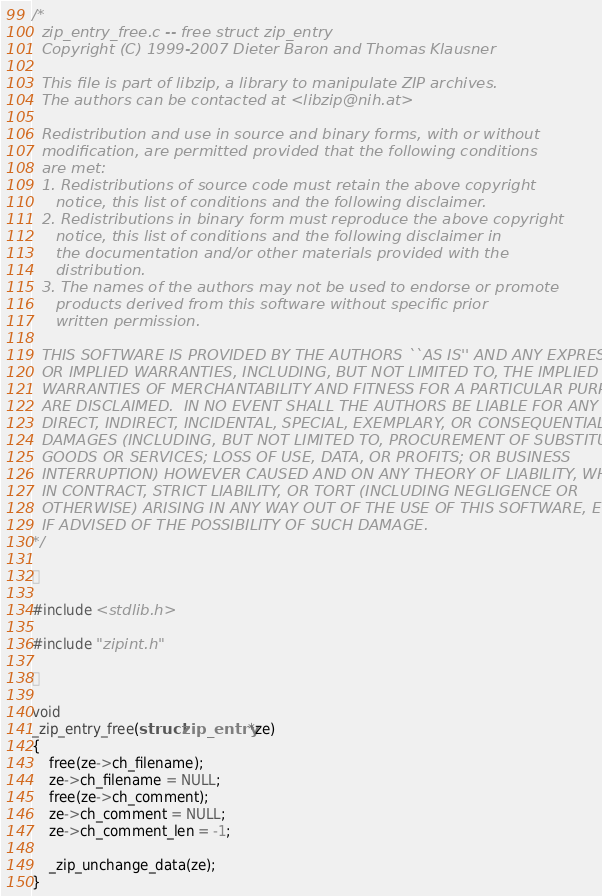Convert code to text. <code><loc_0><loc_0><loc_500><loc_500><_C_>/*
  zip_entry_free.c -- free struct zip_entry
  Copyright (C) 1999-2007 Dieter Baron and Thomas Klausner

  This file is part of libzip, a library to manipulate ZIP archives.
  The authors can be contacted at <libzip@nih.at>

  Redistribution and use in source and binary forms, with or without
  modification, are permitted provided that the following conditions
  are met:
  1. Redistributions of source code must retain the above copyright
     notice, this list of conditions and the following disclaimer.
  2. Redistributions in binary form must reproduce the above copyright
     notice, this list of conditions and the following disclaimer in
     the documentation and/or other materials provided with the
     distribution.
  3. The names of the authors may not be used to endorse or promote
     products derived from this software without specific prior
     written permission.
 
  THIS SOFTWARE IS PROVIDED BY THE AUTHORS ``AS IS'' AND ANY EXPRESS
  OR IMPLIED WARRANTIES, INCLUDING, BUT NOT LIMITED TO, THE IMPLIED
  WARRANTIES OF MERCHANTABILITY AND FITNESS FOR A PARTICULAR PURPOSE
  ARE DISCLAIMED.  IN NO EVENT SHALL THE AUTHORS BE LIABLE FOR ANY
  DIRECT, INDIRECT, INCIDENTAL, SPECIAL, EXEMPLARY, OR CONSEQUENTIAL
  DAMAGES (INCLUDING, BUT NOT LIMITED TO, PROCUREMENT OF SUBSTITUTE
  GOODS OR SERVICES; LOSS OF USE, DATA, OR PROFITS; OR BUSINESS
  INTERRUPTION) HOWEVER CAUSED AND ON ANY THEORY OF LIABILITY, WHETHER
  IN CONTRACT, STRICT LIABILITY, OR TORT (INCLUDING NEGLIGENCE OR
  OTHERWISE) ARISING IN ANY WAY OUT OF THE USE OF THIS SOFTWARE, EVEN
  IF ADVISED OF THE POSSIBILITY OF SUCH DAMAGE.
*/



#include <stdlib.h>

#include "zipint.h"



void
_zip_entry_free(struct zip_entry *ze)
{
    free(ze->ch_filename);
    ze->ch_filename = NULL;
    free(ze->ch_comment);
    ze->ch_comment = NULL;
    ze->ch_comment_len = -1;

    _zip_unchange_data(ze);
}
</code> 